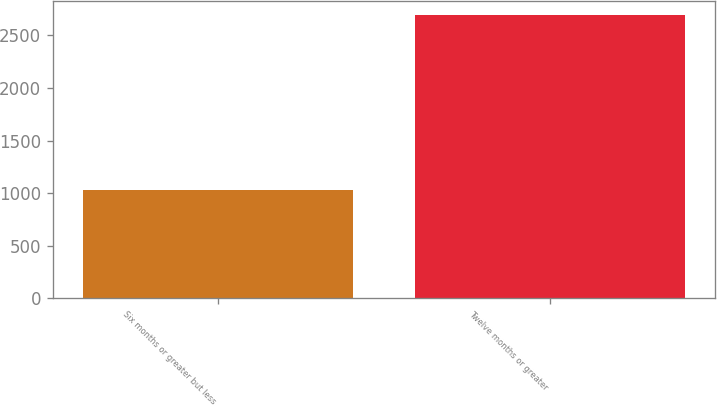Convert chart to OTSL. <chart><loc_0><loc_0><loc_500><loc_500><bar_chart><fcel>Six months or greater but less<fcel>Twelve months or greater<nl><fcel>1028<fcel>2692<nl></chart> 